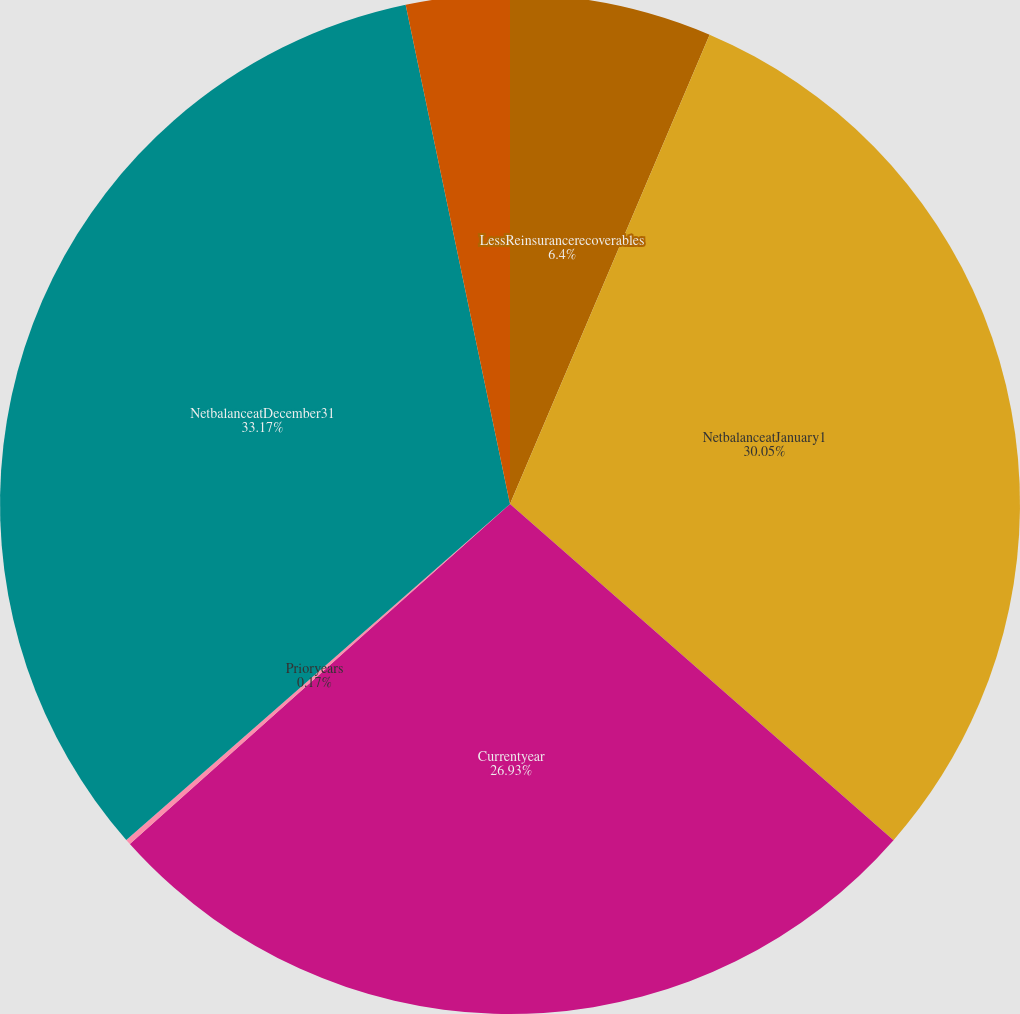Convert chart to OTSL. <chart><loc_0><loc_0><loc_500><loc_500><pie_chart><fcel>LessReinsurancerecoverables<fcel>NetbalanceatJanuary1<fcel>Currentyear<fcel>Prioryears<fcel>NetbalanceatDecember31<fcel>AddReinsurancerecoverables<nl><fcel>6.4%<fcel>30.05%<fcel>26.93%<fcel>0.17%<fcel>33.16%<fcel>3.28%<nl></chart> 